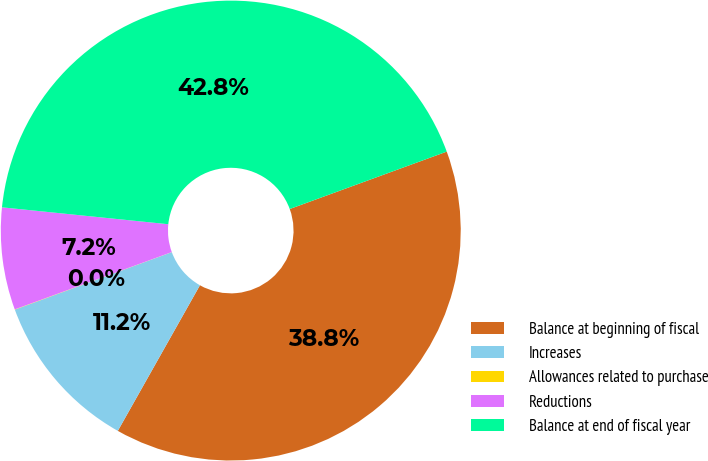Convert chart to OTSL. <chart><loc_0><loc_0><loc_500><loc_500><pie_chart><fcel>Balance at beginning of fiscal<fcel>Increases<fcel>Allowances related to purchase<fcel>Reductions<fcel>Balance at end of fiscal year<nl><fcel>38.75%<fcel>11.24%<fcel>0.02%<fcel>7.18%<fcel>42.81%<nl></chart> 